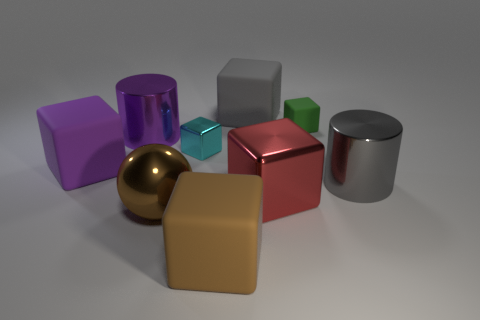There is a large rubber thing that is in front of the gray metal cylinder; is it the same color as the large metal sphere?
Provide a short and direct response. Yes. How big is the gray metallic thing?
Offer a very short reply. Large. What size is the rubber thing right of the big gray matte thing that is behind the green object?
Give a very brief answer. Small. What number of matte things have the same color as the big metal sphere?
Ensure brevity in your answer.  1. How many big metallic balls are there?
Offer a terse response. 1. What number of big brown objects are made of the same material as the large red thing?
Your answer should be very brief. 1. There is a brown rubber object that is the same shape as the purple rubber thing; what size is it?
Ensure brevity in your answer.  Large. What is the purple block made of?
Give a very brief answer. Rubber. The gray object that is behind the gray object that is in front of the big gray thing that is behind the small green thing is made of what material?
Ensure brevity in your answer.  Rubber. Is there any other thing that has the same shape as the small cyan metal object?
Provide a short and direct response. Yes. 